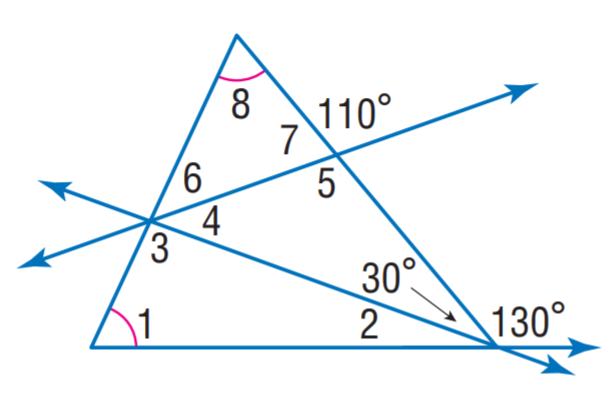Answer the mathemtical geometry problem and directly provide the correct option letter.
Question: Find m \angle 2.
Choices: A: 20 B: 40 C: 45 D: 65 A 